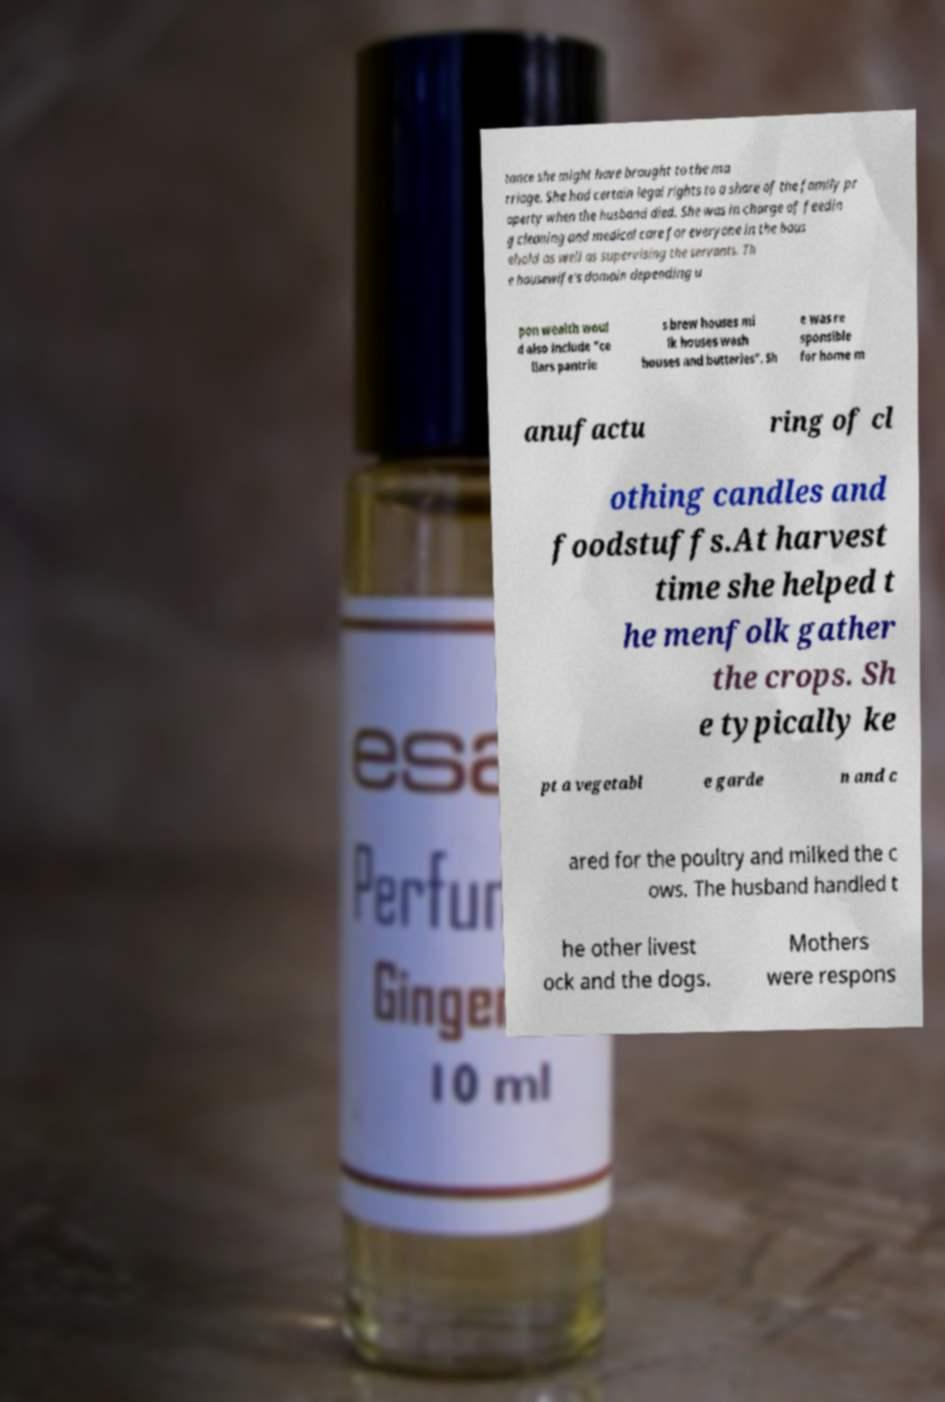There's text embedded in this image that I need extracted. Can you transcribe it verbatim? tance she might have brought to the ma rriage. She had certain legal rights to a share of the family pr operty when the husband died. She was in charge of feedin g cleaning and medical care for everyone in the hous ehold as well as supervising the servants. Th e housewife's domain depending u pon wealth woul d also include "ce llars pantrie s brew houses mi lk houses wash houses and butteries". Sh e was re sponsible for home m anufactu ring of cl othing candles and foodstuffs.At harvest time she helped t he menfolk gather the crops. Sh e typically ke pt a vegetabl e garde n and c ared for the poultry and milked the c ows. The husband handled t he other livest ock and the dogs. Mothers were respons 